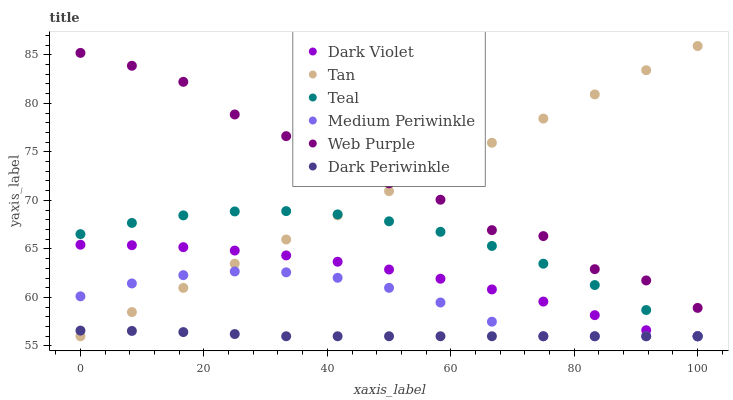Does Dark Periwinkle have the minimum area under the curve?
Answer yes or no. Yes. Does Web Purple have the maximum area under the curve?
Answer yes or no. Yes. Does Dark Violet have the minimum area under the curve?
Answer yes or no. No. Does Dark Violet have the maximum area under the curve?
Answer yes or no. No. Is Tan the smoothest?
Answer yes or no. Yes. Is Web Purple the roughest?
Answer yes or no. Yes. Is Dark Violet the smoothest?
Answer yes or no. No. Is Dark Violet the roughest?
Answer yes or no. No. Does Medium Periwinkle have the lowest value?
Answer yes or no. Yes. Does Web Purple have the lowest value?
Answer yes or no. No. Does Tan have the highest value?
Answer yes or no. Yes. Does Dark Violet have the highest value?
Answer yes or no. No. Is Teal less than Web Purple?
Answer yes or no. Yes. Is Web Purple greater than Medium Periwinkle?
Answer yes or no. Yes. Does Teal intersect Medium Periwinkle?
Answer yes or no. Yes. Is Teal less than Medium Periwinkle?
Answer yes or no. No. Is Teal greater than Medium Periwinkle?
Answer yes or no. No. Does Teal intersect Web Purple?
Answer yes or no. No. 